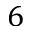Convert formula to latex. <formula><loc_0><loc_0><loc_500><loc_500>6</formula> 